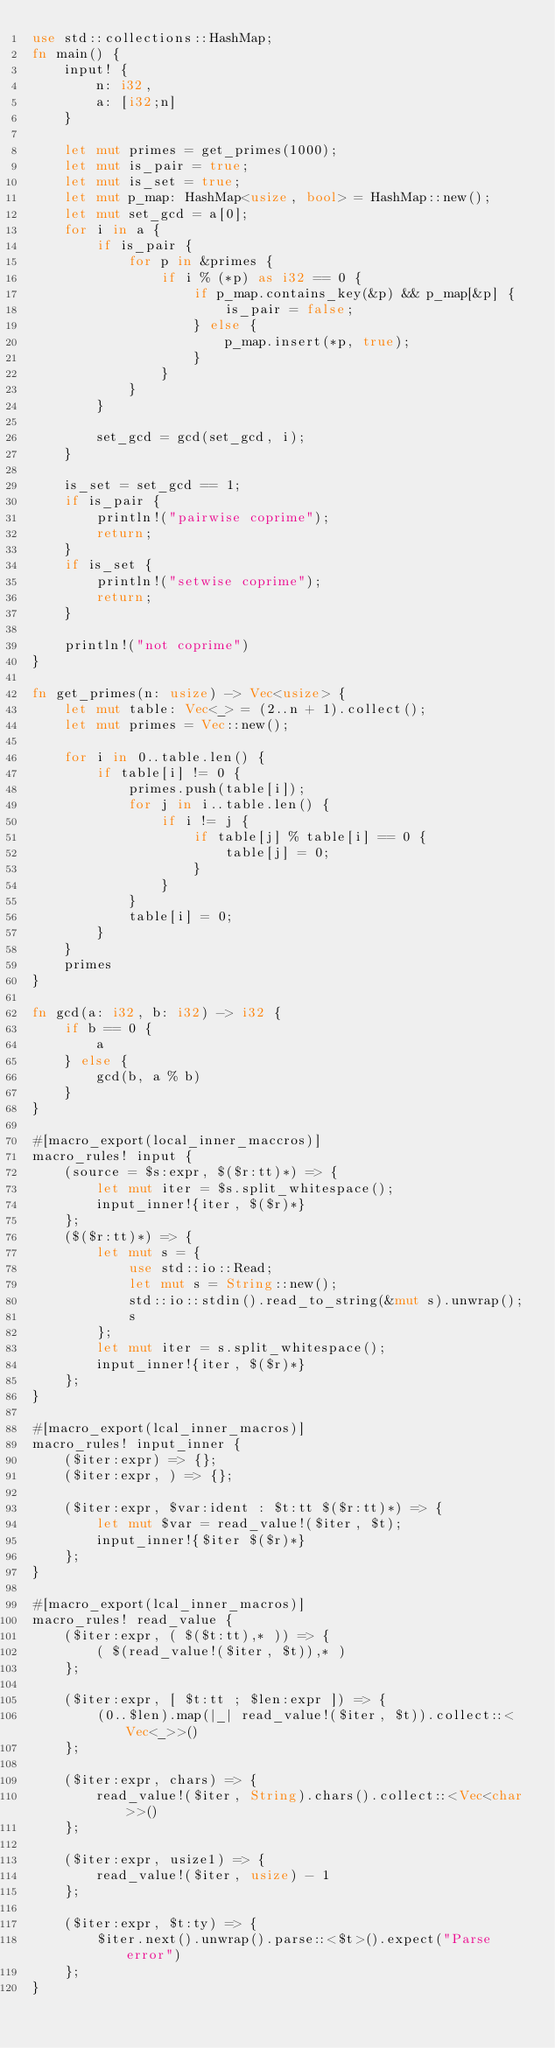<code> <loc_0><loc_0><loc_500><loc_500><_Rust_>use std::collections::HashMap;
fn main() {
    input! {
        n: i32,
        a: [i32;n]
    }

    let mut primes = get_primes(1000);
    let mut is_pair = true;
    let mut is_set = true;
    let mut p_map: HashMap<usize, bool> = HashMap::new();
    let mut set_gcd = a[0];
    for i in a {
        if is_pair {
            for p in &primes {
                if i % (*p) as i32 == 0 {
                    if p_map.contains_key(&p) && p_map[&p] {
                        is_pair = false;
                    } else {
                        p_map.insert(*p, true);
                    }
                }
            }
        }

        set_gcd = gcd(set_gcd, i);
    }

    is_set = set_gcd == 1;
    if is_pair {
        println!("pairwise coprime");
        return;
    }
    if is_set {
        println!("setwise coprime");
        return;
    }

    println!("not coprime")
}

fn get_primes(n: usize) -> Vec<usize> {
    let mut table: Vec<_> = (2..n + 1).collect();
    let mut primes = Vec::new();

    for i in 0..table.len() {
        if table[i] != 0 {
            primes.push(table[i]);
            for j in i..table.len() {
                if i != j {
                    if table[j] % table[i] == 0 {
                        table[j] = 0;
                    }
                }
            }
            table[i] = 0;
        }
    }
    primes
}

fn gcd(a: i32, b: i32) -> i32 {
    if b == 0 {
        a
    } else {
        gcd(b, a % b)
    }
}

#[macro_export(local_inner_maccros)]
macro_rules! input {
    (source = $s:expr, $($r:tt)*) => {
        let mut iter = $s.split_whitespace();
        input_inner!{iter, $($r)*}
    };
    ($($r:tt)*) => {
        let mut s = {
            use std::io::Read;
            let mut s = String::new();
            std::io::stdin().read_to_string(&mut s).unwrap();
            s
        };
        let mut iter = s.split_whitespace();
        input_inner!{iter, $($r)*}
    };
}

#[macro_export(lcal_inner_macros)]
macro_rules! input_inner {
    ($iter:expr) => {};
    ($iter:expr, ) => {};

    ($iter:expr, $var:ident : $t:tt $($r:tt)*) => {
        let mut $var = read_value!($iter, $t);
        input_inner!{$iter $($r)*}
    };
}

#[macro_export(lcal_inner_macros)]
macro_rules! read_value {
    ($iter:expr, ( $($t:tt),* )) => {
        ( $(read_value!($iter, $t)),* )
    };

    ($iter:expr, [ $t:tt ; $len:expr ]) => {
        (0..$len).map(|_| read_value!($iter, $t)).collect::<Vec<_>>()
    };

    ($iter:expr, chars) => {
        read_value!($iter, String).chars().collect::<Vec<char>>()
    };

    ($iter:expr, usize1) => {
        read_value!($iter, usize) - 1
    };

    ($iter:expr, $t:ty) => {
        $iter.next().unwrap().parse::<$t>().expect("Parse error")
    };
}
</code> 